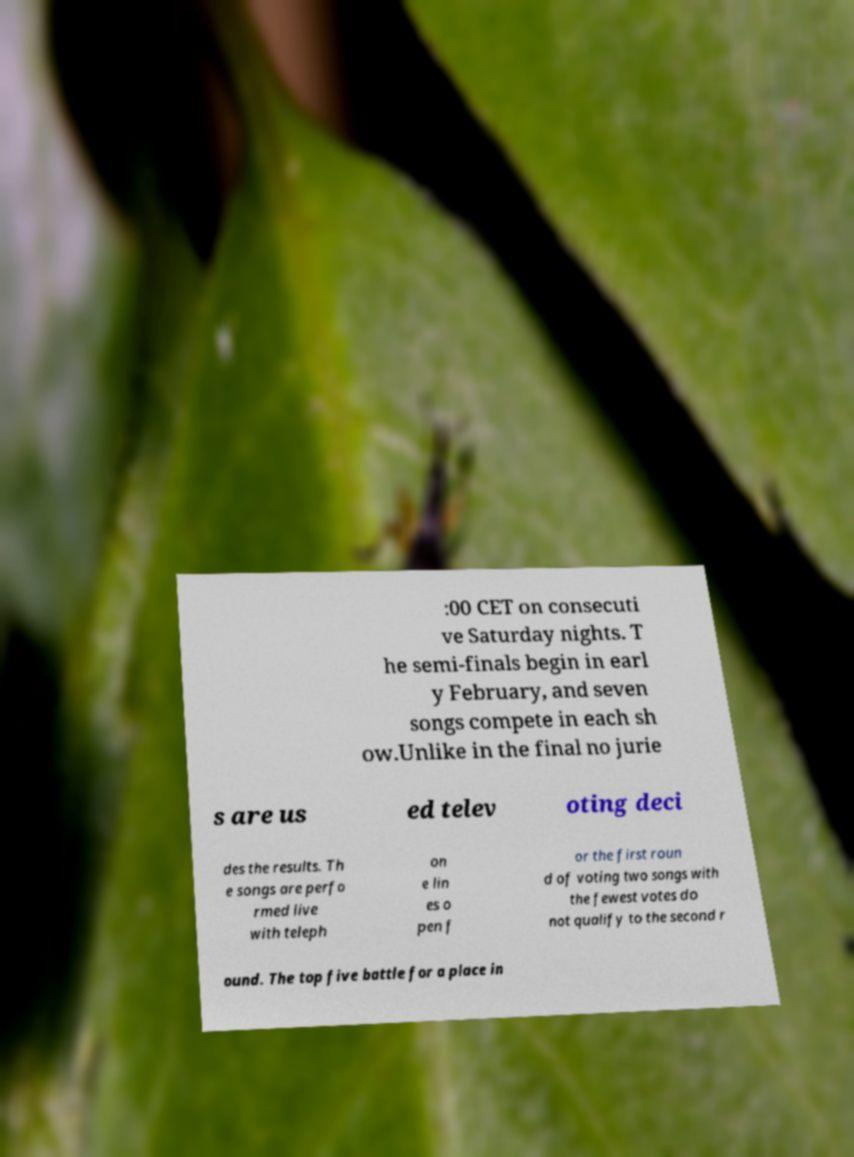There's text embedded in this image that I need extracted. Can you transcribe it verbatim? :00 CET on consecuti ve Saturday nights. T he semi-finals begin in earl y February, and seven songs compete in each sh ow.Unlike in the final no jurie s are us ed telev oting deci des the results. Th e songs are perfo rmed live with teleph on e lin es o pen f or the first roun d of voting two songs with the fewest votes do not qualify to the second r ound. The top five battle for a place in 